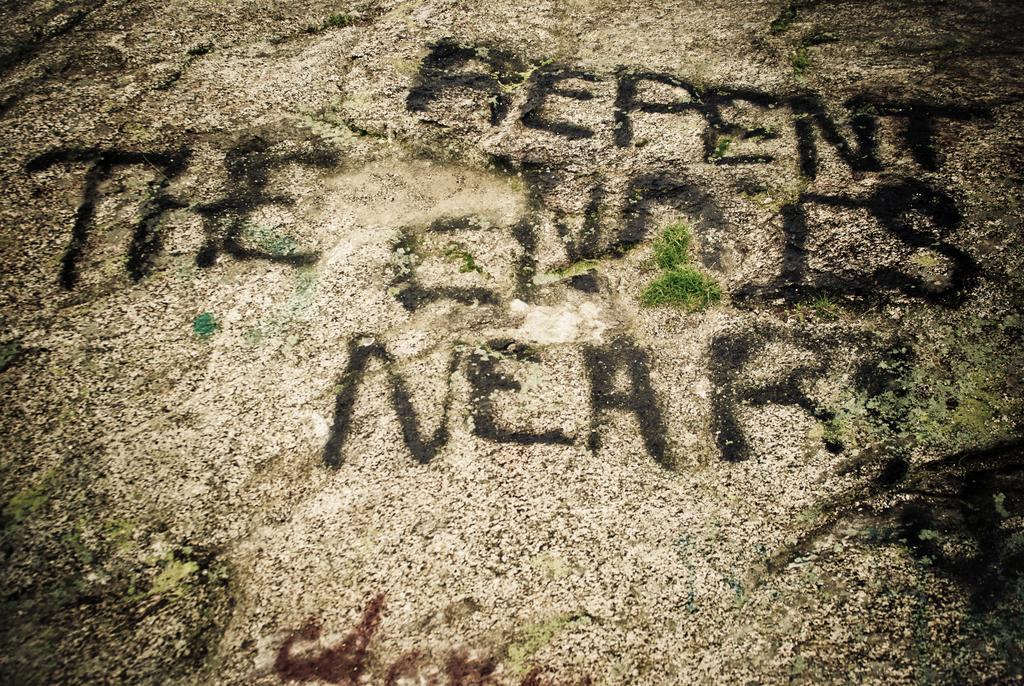In one or two sentences, can you explain what this image depicts? This is a zoomed in picture. In the foreground we can see the ground and we can see the text is written on the ground. 